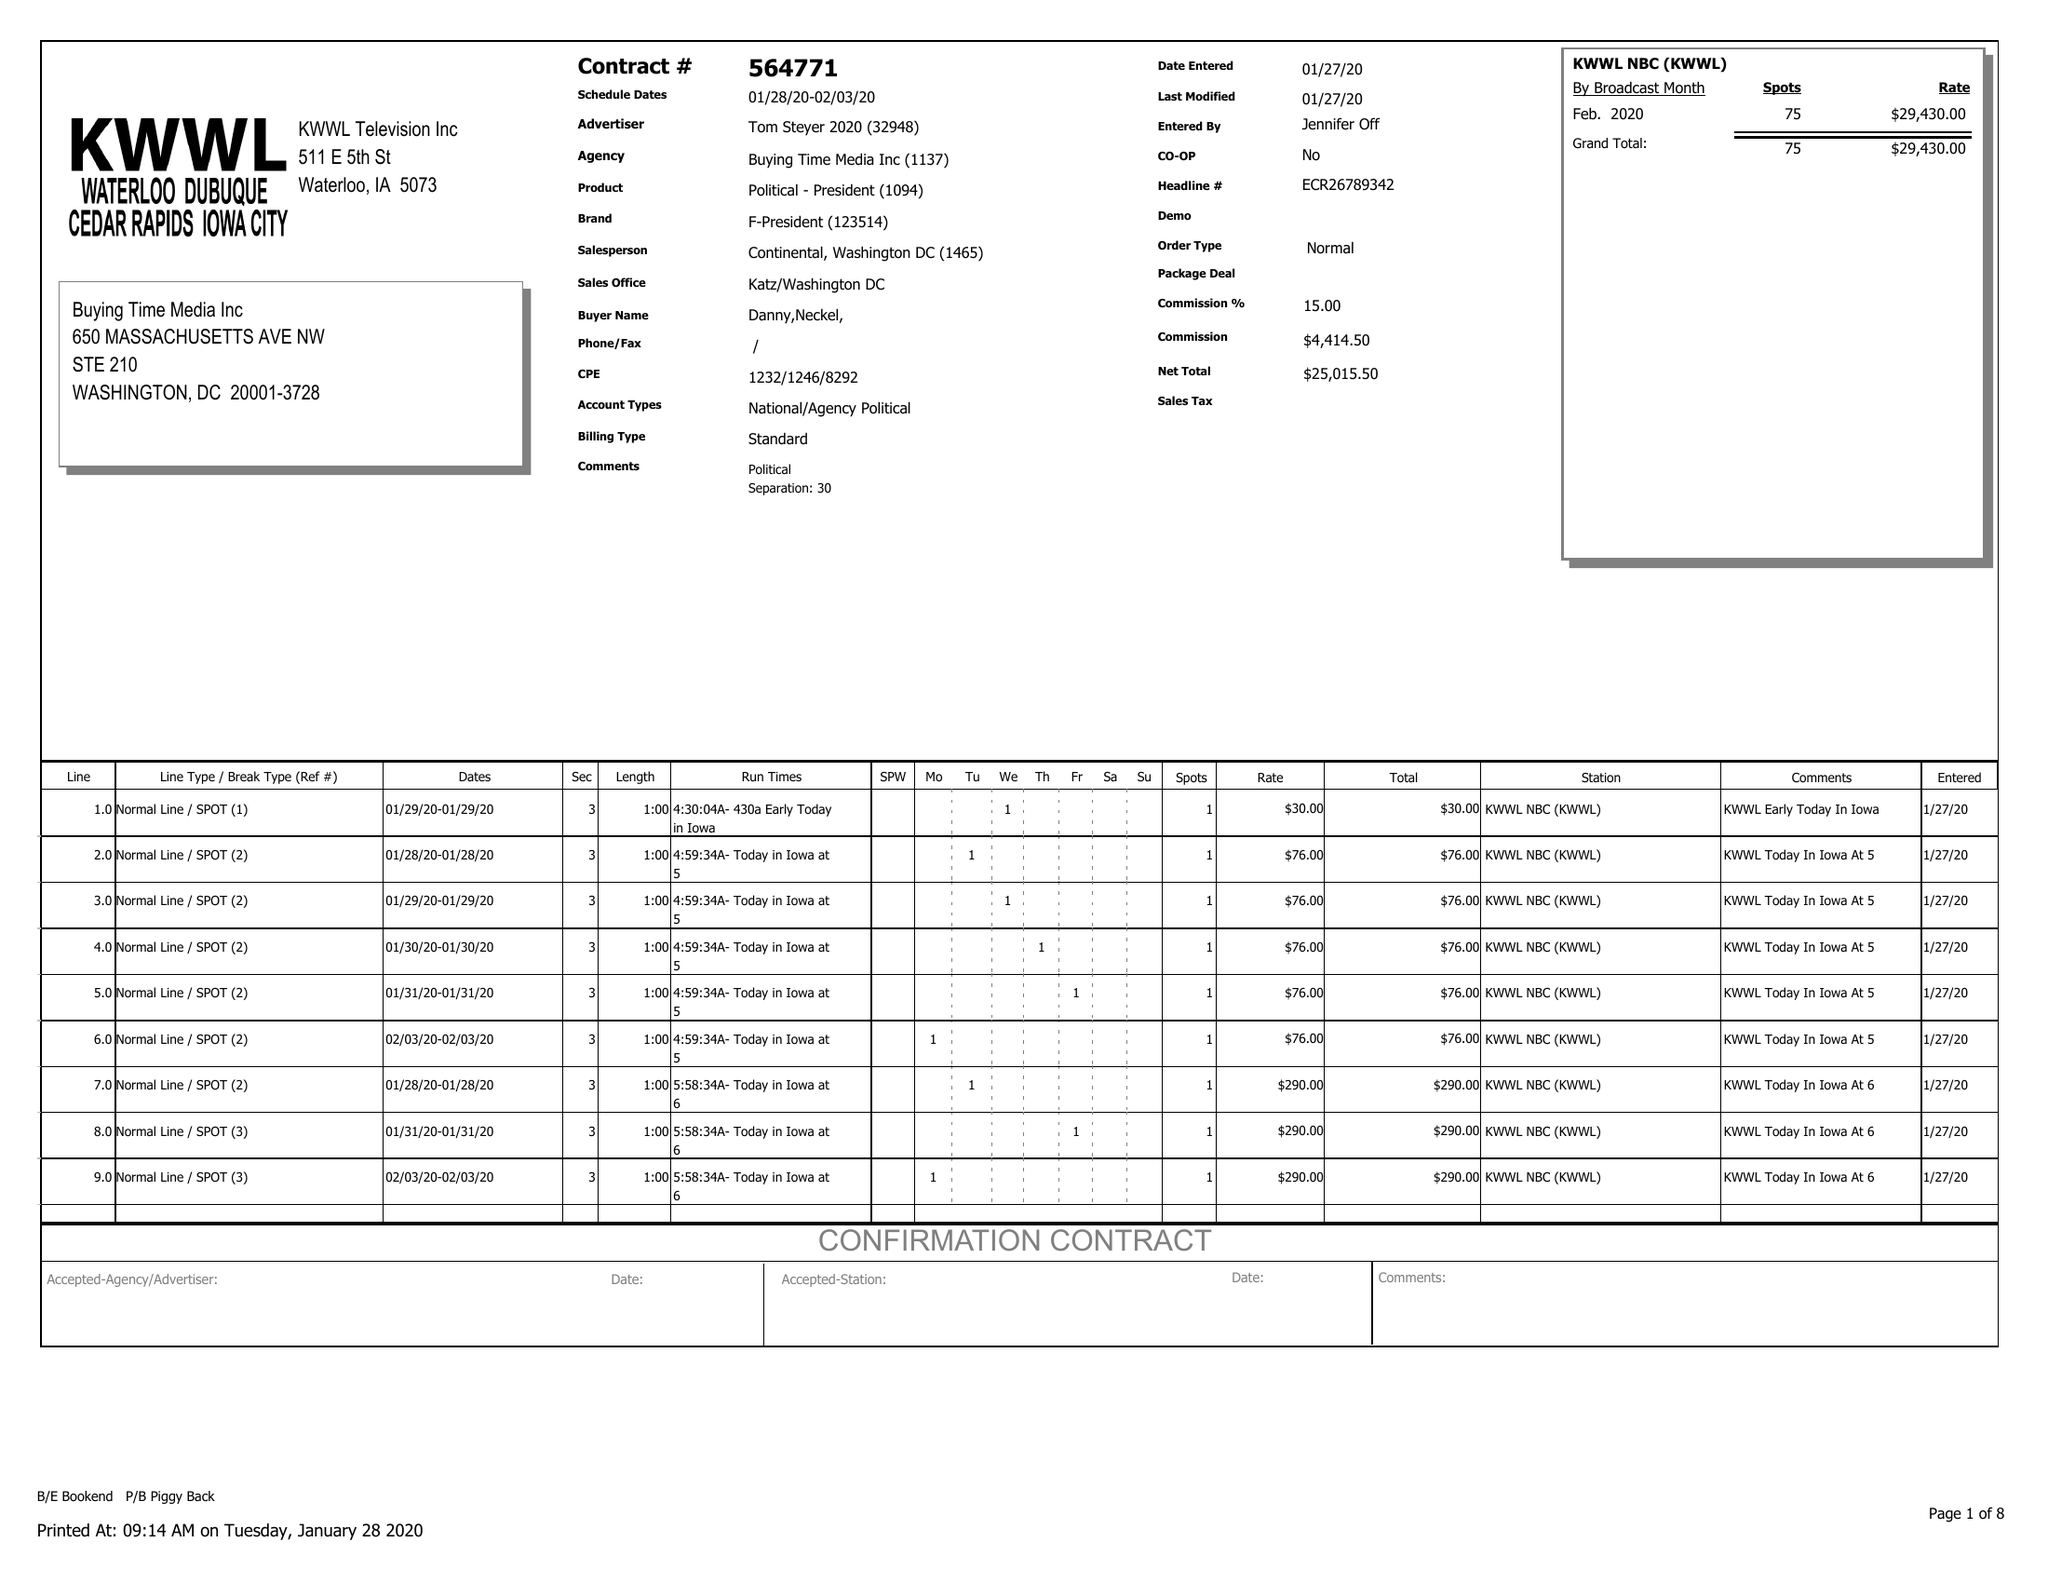What is the value for the flight_from?
Answer the question using a single word or phrase. 01/28/20 